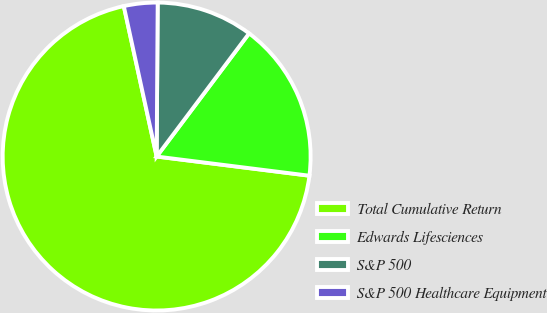<chart> <loc_0><loc_0><loc_500><loc_500><pie_chart><fcel>Total Cumulative Return<fcel>Edwards Lifesciences<fcel>S&P 500<fcel>S&P 500 Healthcare Equipment<nl><fcel>69.59%<fcel>16.74%<fcel>10.14%<fcel>3.53%<nl></chart> 